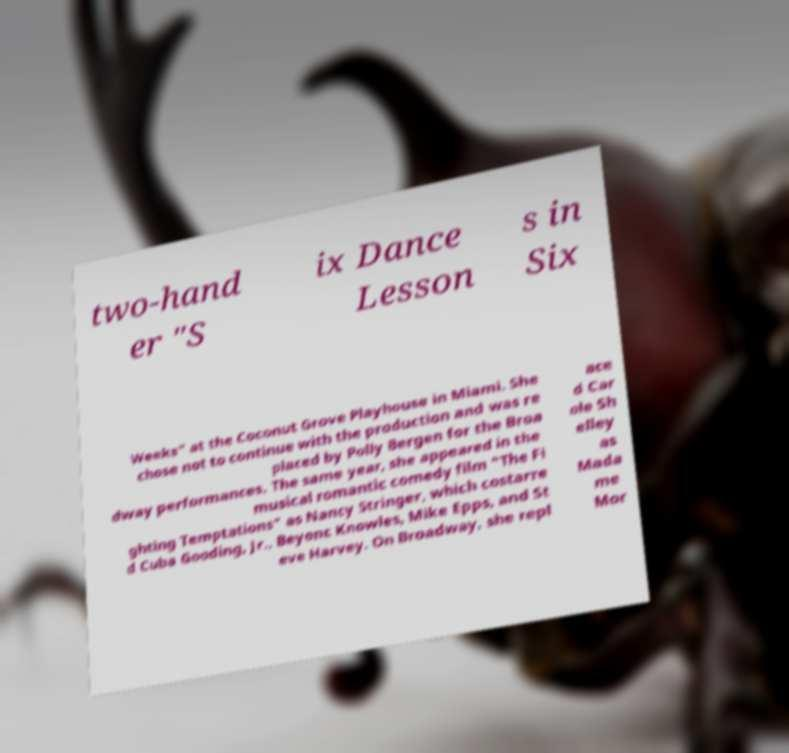I need the written content from this picture converted into text. Can you do that? two-hand er "S ix Dance Lesson s in Six Weeks" at the Coconut Grove Playhouse in Miami. She chose not to continue with the production and was re placed by Polly Bergen for the Broa dway performances. The same year, she appeared in the musical romantic comedy film "The Fi ghting Temptations" as Nancy Stringer, which costarre d Cuba Gooding, Jr., Beyonc Knowles, Mike Epps, and St eve Harvey. On Broadway, she repl ace d Car ole Sh elley as Mada me Mor 